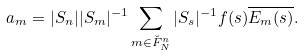<formula> <loc_0><loc_0><loc_500><loc_500>a _ { m } = | S _ { n } | | S _ { m } | ^ { - 1 } \sum _ { { m } \in \breve { F } _ { N } ^ { n } } | S _ { s } | ^ { - 1 } f ( { s } ) \overline { E _ { m } ( { s } ) } .</formula> 